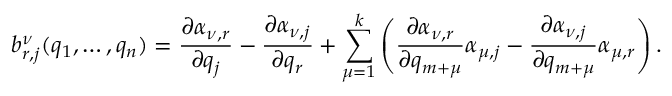<formula> <loc_0><loc_0><loc_500><loc_500>b _ { r , j } ^ { \nu } ( q _ { 1 } , \dots , q _ { n } ) = \frac { \partial \alpha _ { \nu , r } } { \partial q _ { j } } - \frac { \partial \alpha _ { \nu , j } } { \partial q _ { r } } + \sum _ { \mu = 1 } ^ { k } \left ( \frac { \partial \alpha _ { \nu , r } } { \partial q _ { m + \mu } } \alpha _ { \mu , j } - \frac { \partial \alpha _ { \nu , j } } { \partial q _ { m + \mu } } \alpha _ { \mu , r } \right ) .</formula> 